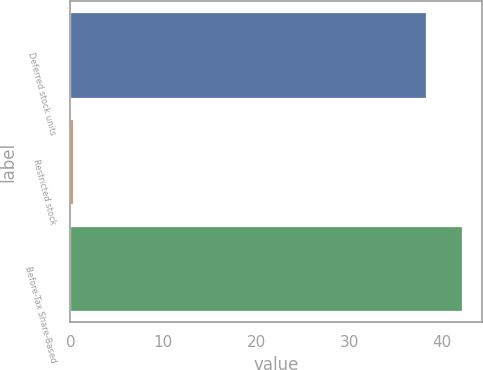Convert chart. <chart><loc_0><loc_0><loc_500><loc_500><bar_chart><fcel>Deferred stock units<fcel>Restricted stock<fcel>Before-Tax Share-Based<nl><fcel>38.3<fcel>0.3<fcel>42.15<nl></chart> 